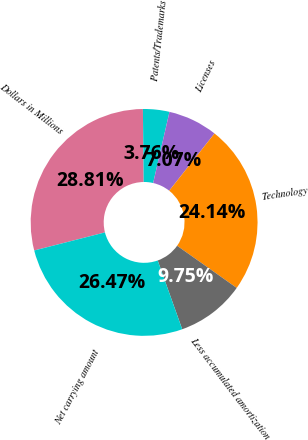Convert chart. <chart><loc_0><loc_0><loc_500><loc_500><pie_chart><fcel>Dollars in Millions<fcel>Patents/Trademarks<fcel>Licenses<fcel>Technology<fcel>Less accumulated amortization<fcel>Net carrying amount<nl><fcel>28.81%<fcel>3.76%<fcel>7.07%<fcel>24.14%<fcel>9.75%<fcel>26.47%<nl></chart> 